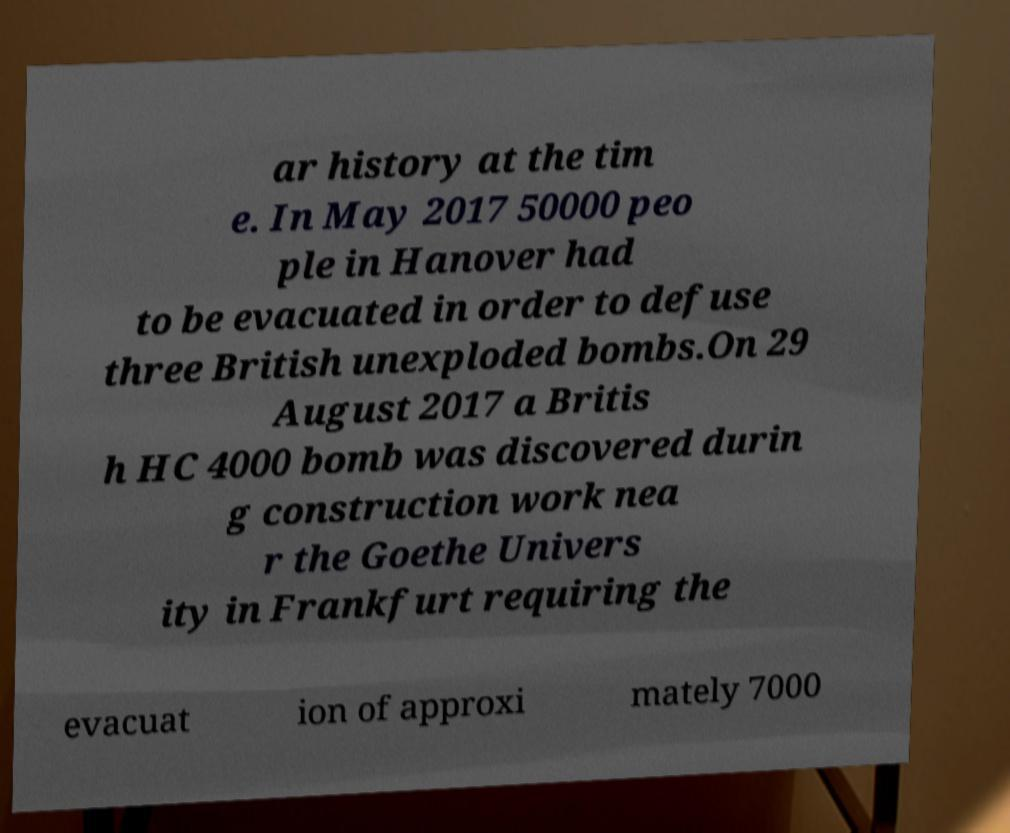For documentation purposes, I need the text within this image transcribed. Could you provide that? ar history at the tim e. In May 2017 50000 peo ple in Hanover had to be evacuated in order to defuse three British unexploded bombs.On 29 August 2017 a Britis h HC 4000 bomb was discovered durin g construction work nea r the Goethe Univers ity in Frankfurt requiring the evacuat ion of approxi mately 7000 